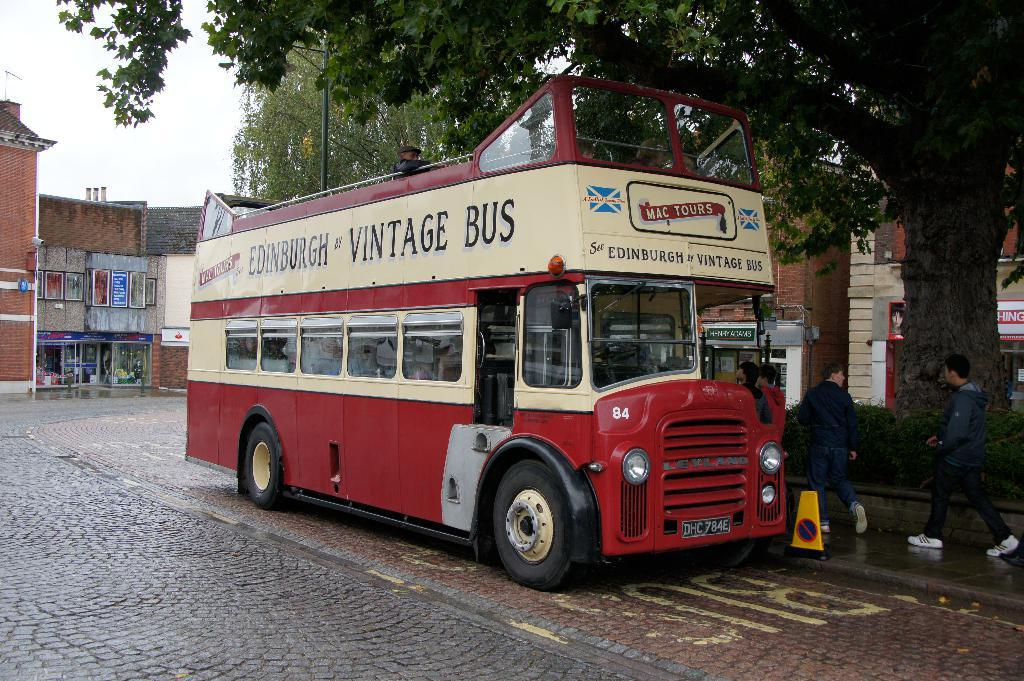<image>
Present a compact description of the photo's key features. Red and white bus which says "Vintage Bus" on it. 